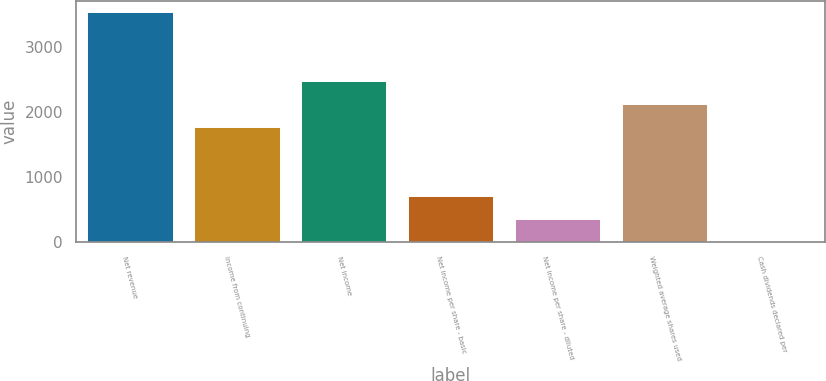<chart> <loc_0><loc_0><loc_500><loc_500><bar_chart><fcel>Net revenue<fcel>Income from continuing<fcel>Net income<fcel>Net income per share - basic<fcel>Net income per share - diluted<fcel>Weighted average shares used<fcel>Cash dividends declared per<nl><fcel>3543<fcel>1771.65<fcel>2480.19<fcel>708.84<fcel>354.57<fcel>2125.92<fcel>0.3<nl></chart> 